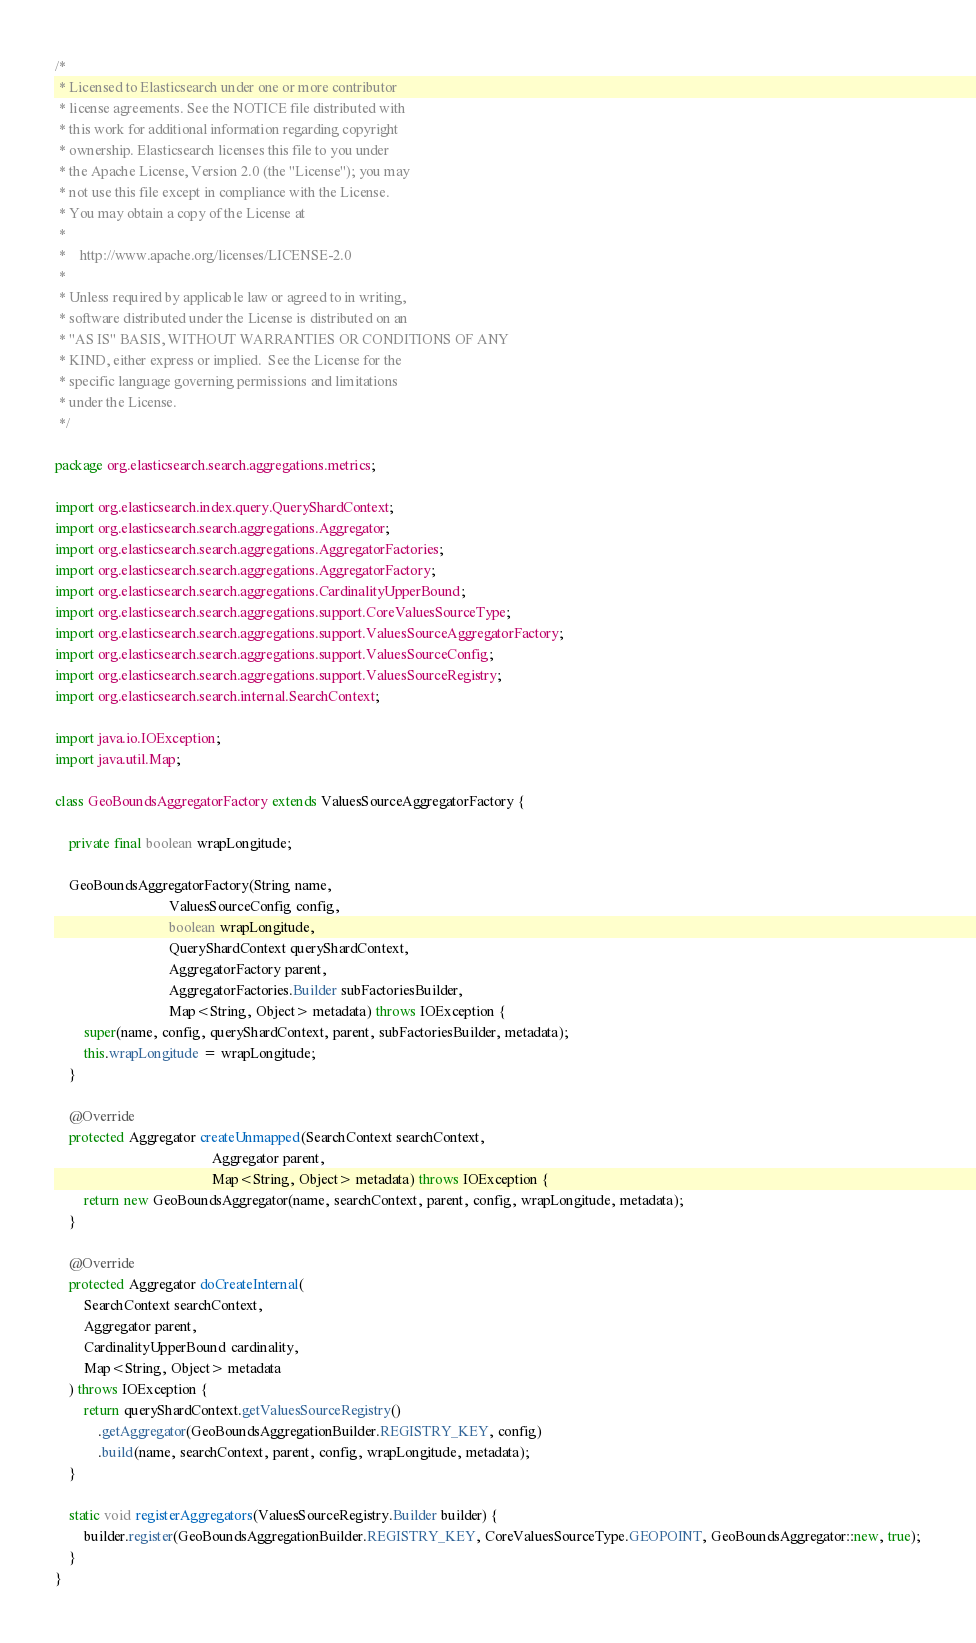<code> <loc_0><loc_0><loc_500><loc_500><_Java_>/*
 * Licensed to Elasticsearch under one or more contributor
 * license agreements. See the NOTICE file distributed with
 * this work for additional information regarding copyright
 * ownership. Elasticsearch licenses this file to you under
 * the Apache License, Version 2.0 (the "License"); you may
 * not use this file except in compliance with the License.
 * You may obtain a copy of the License at
 *
 *    http://www.apache.org/licenses/LICENSE-2.0
 *
 * Unless required by applicable law or agreed to in writing,
 * software distributed under the License is distributed on an
 * "AS IS" BASIS, WITHOUT WARRANTIES OR CONDITIONS OF ANY
 * KIND, either express or implied.  See the License for the
 * specific language governing permissions and limitations
 * under the License.
 */

package org.elasticsearch.search.aggregations.metrics;

import org.elasticsearch.index.query.QueryShardContext;
import org.elasticsearch.search.aggregations.Aggregator;
import org.elasticsearch.search.aggregations.AggregatorFactories;
import org.elasticsearch.search.aggregations.AggregatorFactory;
import org.elasticsearch.search.aggregations.CardinalityUpperBound;
import org.elasticsearch.search.aggregations.support.CoreValuesSourceType;
import org.elasticsearch.search.aggregations.support.ValuesSourceAggregatorFactory;
import org.elasticsearch.search.aggregations.support.ValuesSourceConfig;
import org.elasticsearch.search.aggregations.support.ValuesSourceRegistry;
import org.elasticsearch.search.internal.SearchContext;

import java.io.IOException;
import java.util.Map;

class GeoBoundsAggregatorFactory extends ValuesSourceAggregatorFactory {

    private final boolean wrapLongitude;

    GeoBoundsAggregatorFactory(String name,
                                ValuesSourceConfig config,
                                boolean wrapLongitude,
                                QueryShardContext queryShardContext,
                                AggregatorFactory parent,
                                AggregatorFactories.Builder subFactoriesBuilder,
                                Map<String, Object> metadata) throws IOException {
        super(name, config, queryShardContext, parent, subFactoriesBuilder, metadata);
        this.wrapLongitude = wrapLongitude;
    }

    @Override
    protected Aggregator createUnmapped(SearchContext searchContext,
                                            Aggregator parent,
                                            Map<String, Object> metadata) throws IOException {
        return new GeoBoundsAggregator(name, searchContext, parent, config, wrapLongitude, metadata);
    }

    @Override
    protected Aggregator doCreateInternal(
        SearchContext searchContext,
        Aggregator parent,
        CardinalityUpperBound cardinality,
        Map<String, Object> metadata
    ) throws IOException {
        return queryShardContext.getValuesSourceRegistry()
            .getAggregator(GeoBoundsAggregationBuilder.REGISTRY_KEY, config)
            .build(name, searchContext, parent, config, wrapLongitude, metadata);
    }

    static void registerAggregators(ValuesSourceRegistry.Builder builder) {
        builder.register(GeoBoundsAggregationBuilder.REGISTRY_KEY, CoreValuesSourceType.GEOPOINT, GeoBoundsAggregator::new, true);
    }
}
</code> 